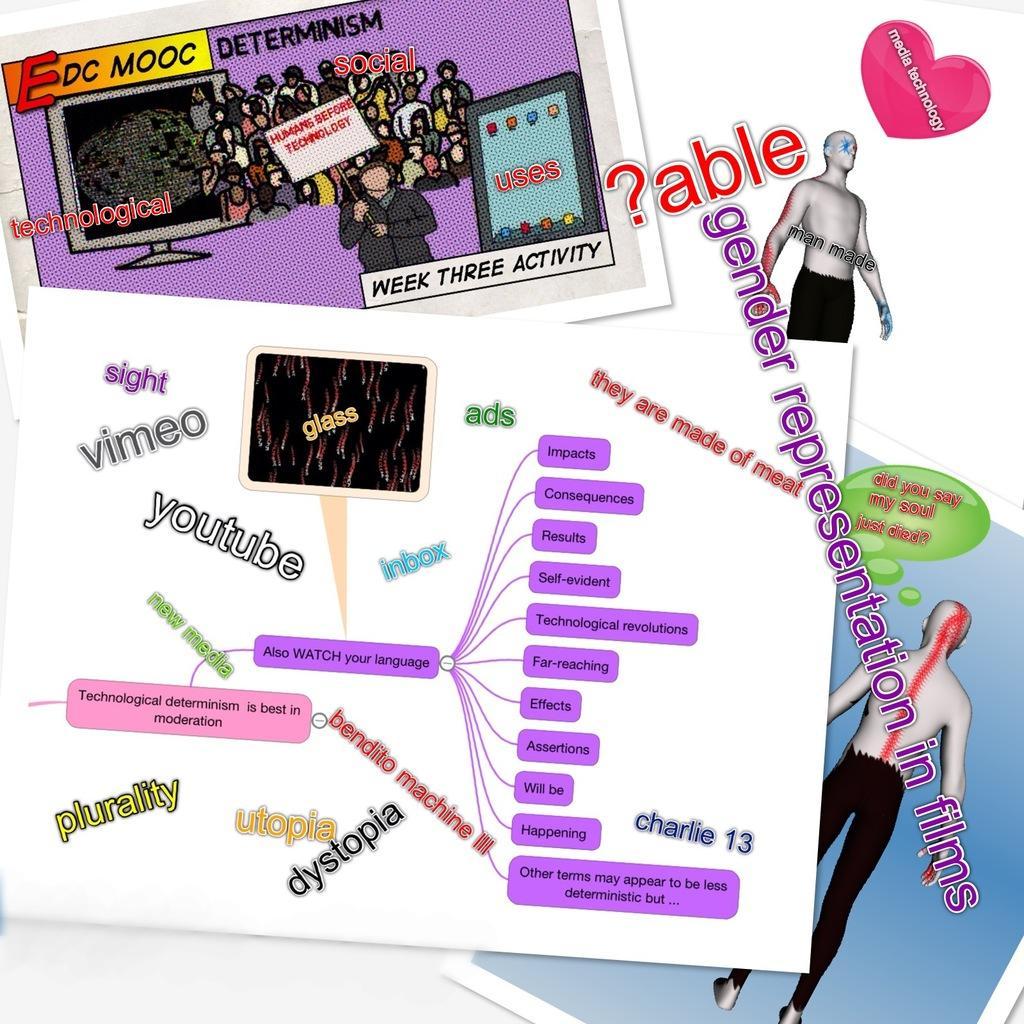Could you give a brief overview of what you see in this image? In this picture we can observe two animated persons. We can observe violet color boxes in which there are black color words. There is some text on the picture. The background is in white color. 